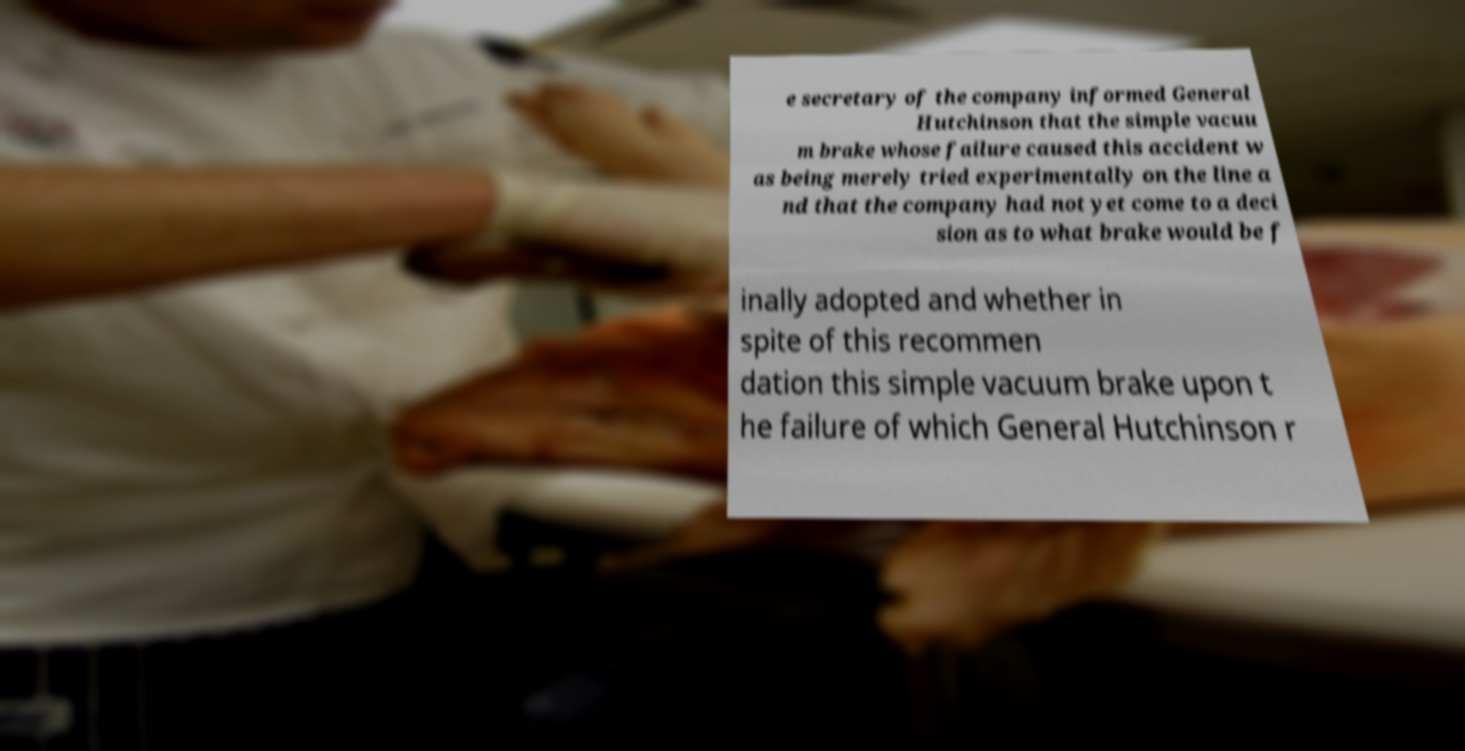Could you extract and type out the text from this image? e secretary of the company informed General Hutchinson that the simple vacuu m brake whose failure caused this accident w as being merely tried experimentally on the line a nd that the company had not yet come to a deci sion as to what brake would be f inally adopted and whether in spite of this recommen dation this simple vacuum brake upon t he failure of which General Hutchinson r 